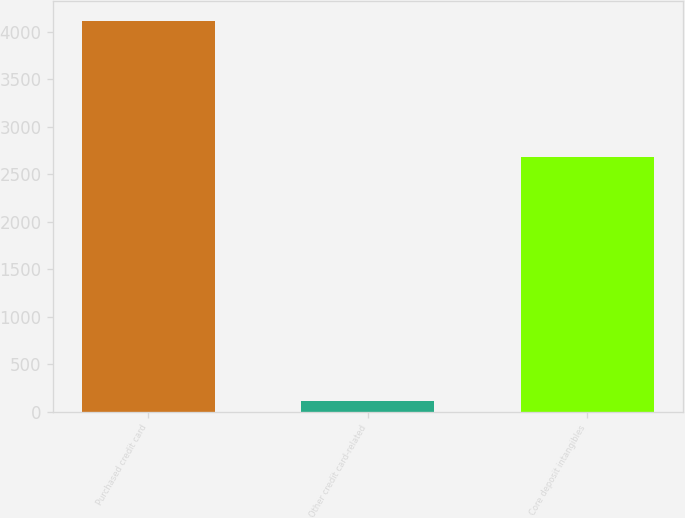Convert chart to OTSL. <chart><loc_0><loc_0><loc_500><loc_500><bar_chart><fcel>Purchased credit card<fcel>Other credit card-related<fcel>Core deposit intangibles<nl><fcel>4116<fcel>109<fcel>2683<nl></chart> 